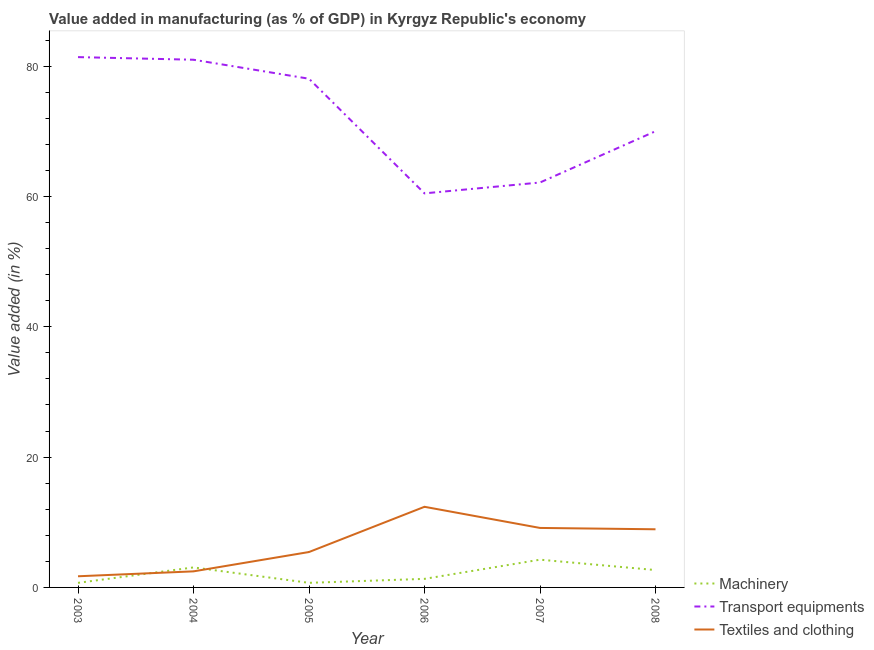How many different coloured lines are there?
Your response must be concise. 3. Is the number of lines equal to the number of legend labels?
Ensure brevity in your answer.  Yes. What is the value added in manufacturing textile and clothing in 2006?
Ensure brevity in your answer.  12.37. Across all years, what is the maximum value added in manufacturing machinery?
Your answer should be compact. 4.26. Across all years, what is the minimum value added in manufacturing transport equipments?
Your answer should be very brief. 60.48. What is the total value added in manufacturing textile and clothing in the graph?
Keep it short and to the point. 40.04. What is the difference between the value added in manufacturing transport equipments in 2007 and that in 2008?
Ensure brevity in your answer.  -7.87. What is the difference between the value added in manufacturing machinery in 2006 and the value added in manufacturing textile and clothing in 2005?
Give a very brief answer. -4.12. What is the average value added in manufacturing textile and clothing per year?
Provide a succinct answer. 6.67. In the year 2007, what is the difference between the value added in manufacturing machinery and value added in manufacturing textile and clothing?
Provide a succinct answer. -4.87. In how many years, is the value added in manufacturing textile and clothing greater than 20 %?
Your response must be concise. 0. What is the ratio of the value added in manufacturing textile and clothing in 2004 to that in 2006?
Ensure brevity in your answer.  0.2. What is the difference between the highest and the second highest value added in manufacturing textile and clothing?
Your answer should be compact. 3.25. What is the difference between the highest and the lowest value added in manufacturing machinery?
Provide a short and direct response. 3.56. Is it the case that in every year, the sum of the value added in manufacturing machinery and value added in manufacturing transport equipments is greater than the value added in manufacturing textile and clothing?
Your answer should be very brief. Yes. How many lines are there?
Your answer should be compact. 3. Does the graph contain grids?
Keep it short and to the point. No. How many legend labels are there?
Your response must be concise. 3. What is the title of the graph?
Your answer should be very brief. Value added in manufacturing (as % of GDP) in Kyrgyz Republic's economy. What is the label or title of the Y-axis?
Ensure brevity in your answer.  Value added (in %). What is the Value added (in %) in Machinery in 2003?
Ensure brevity in your answer.  0.7. What is the Value added (in %) of Transport equipments in 2003?
Provide a short and direct response. 81.39. What is the Value added (in %) of Textiles and clothing in 2003?
Offer a very short reply. 1.71. What is the Value added (in %) in Machinery in 2004?
Provide a short and direct response. 3.07. What is the Value added (in %) in Transport equipments in 2004?
Provide a short and direct response. 80.98. What is the Value added (in %) in Textiles and clothing in 2004?
Your response must be concise. 2.46. What is the Value added (in %) in Machinery in 2005?
Provide a succinct answer. 0.7. What is the Value added (in %) of Transport equipments in 2005?
Your answer should be compact. 78.07. What is the Value added (in %) in Textiles and clothing in 2005?
Give a very brief answer. 5.43. What is the Value added (in %) in Machinery in 2006?
Provide a succinct answer. 1.31. What is the Value added (in %) of Transport equipments in 2006?
Your answer should be compact. 60.48. What is the Value added (in %) of Textiles and clothing in 2006?
Make the answer very short. 12.37. What is the Value added (in %) of Machinery in 2007?
Make the answer very short. 4.26. What is the Value added (in %) of Transport equipments in 2007?
Provide a short and direct response. 62.14. What is the Value added (in %) in Textiles and clothing in 2007?
Offer a terse response. 9.13. What is the Value added (in %) in Machinery in 2008?
Offer a very short reply. 2.67. What is the Value added (in %) of Transport equipments in 2008?
Give a very brief answer. 70.01. What is the Value added (in %) of Textiles and clothing in 2008?
Your answer should be compact. 8.92. Across all years, what is the maximum Value added (in %) in Machinery?
Offer a very short reply. 4.26. Across all years, what is the maximum Value added (in %) in Transport equipments?
Provide a succinct answer. 81.39. Across all years, what is the maximum Value added (in %) of Textiles and clothing?
Your response must be concise. 12.37. Across all years, what is the minimum Value added (in %) in Machinery?
Provide a succinct answer. 0.7. Across all years, what is the minimum Value added (in %) of Transport equipments?
Provide a short and direct response. 60.48. Across all years, what is the minimum Value added (in %) of Textiles and clothing?
Ensure brevity in your answer.  1.71. What is the total Value added (in %) in Machinery in the graph?
Keep it short and to the point. 12.72. What is the total Value added (in %) in Transport equipments in the graph?
Your answer should be very brief. 433.07. What is the total Value added (in %) of Textiles and clothing in the graph?
Your answer should be very brief. 40.04. What is the difference between the Value added (in %) in Machinery in 2003 and that in 2004?
Ensure brevity in your answer.  -2.37. What is the difference between the Value added (in %) in Transport equipments in 2003 and that in 2004?
Give a very brief answer. 0.4. What is the difference between the Value added (in %) of Textiles and clothing in 2003 and that in 2004?
Provide a short and direct response. -0.75. What is the difference between the Value added (in %) in Machinery in 2003 and that in 2005?
Provide a short and direct response. -0. What is the difference between the Value added (in %) of Transport equipments in 2003 and that in 2005?
Give a very brief answer. 3.32. What is the difference between the Value added (in %) of Textiles and clothing in 2003 and that in 2005?
Offer a terse response. -3.72. What is the difference between the Value added (in %) of Machinery in 2003 and that in 2006?
Give a very brief answer. -0.61. What is the difference between the Value added (in %) of Transport equipments in 2003 and that in 2006?
Offer a terse response. 20.91. What is the difference between the Value added (in %) in Textiles and clothing in 2003 and that in 2006?
Keep it short and to the point. -10.66. What is the difference between the Value added (in %) of Machinery in 2003 and that in 2007?
Give a very brief answer. -3.56. What is the difference between the Value added (in %) in Transport equipments in 2003 and that in 2007?
Provide a short and direct response. 19.24. What is the difference between the Value added (in %) of Textiles and clothing in 2003 and that in 2007?
Give a very brief answer. -7.42. What is the difference between the Value added (in %) of Machinery in 2003 and that in 2008?
Your answer should be very brief. -1.96. What is the difference between the Value added (in %) in Transport equipments in 2003 and that in 2008?
Keep it short and to the point. 11.37. What is the difference between the Value added (in %) of Textiles and clothing in 2003 and that in 2008?
Make the answer very short. -7.21. What is the difference between the Value added (in %) of Machinery in 2004 and that in 2005?
Offer a terse response. 2.37. What is the difference between the Value added (in %) of Transport equipments in 2004 and that in 2005?
Offer a terse response. 2.92. What is the difference between the Value added (in %) of Textiles and clothing in 2004 and that in 2005?
Provide a succinct answer. -2.97. What is the difference between the Value added (in %) in Machinery in 2004 and that in 2006?
Your answer should be very brief. 1.76. What is the difference between the Value added (in %) of Transport equipments in 2004 and that in 2006?
Your response must be concise. 20.51. What is the difference between the Value added (in %) in Textiles and clothing in 2004 and that in 2006?
Your response must be concise. -9.91. What is the difference between the Value added (in %) of Machinery in 2004 and that in 2007?
Provide a short and direct response. -1.19. What is the difference between the Value added (in %) in Transport equipments in 2004 and that in 2007?
Offer a terse response. 18.84. What is the difference between the Value added (in %) of Textiles and clothing in 2004 and that in 2007?
Your answer should be compact. -6.66. What is the difference between the Value added (in %) in Machinery in 2004 and that in 2008?
Provide a short and direct response. 0.4. What is the difference between the Value added (in %) of Transport equipments in 2004 and that in 2008?
Give a very brief answer. 10.97. What is the difference between the Value added (in %) in Textiles and clothing in 2004 and that in 2008?
Give a very brief answer. -6.46. What is the difference between the Value added (in %) in Machinery in 2005 and that in 2006?
Your answer should be very brief. -0.61. What is the difference between the Value added (in %) of Transport equipments in 2005 and that in 2006?
Provide a succinct answer. 17.59. What is the difference between the Value added (in %) of Textiles and clothing in 2005 and that in 2006?
Your answer should be compact. -6.94. What is the difference between the Value added (in %) of Machinery in 2005 and that in 2007?
Your answer should be compact. -3.55. What is the difference between the Value added (in %) of Transport equipments in 2005 and that in 2007?
Give a very brief answer. 15.93. What is the difference between the Value added (in %) of Textiles and clothing in 2005 and that in 2007?
Make the answer very short. -3.7. What is the difference between the Value added (in %) in Machinery in 2005 and that in 2008?
Provide a succinct answer. -1.96. What is the difference between the Value added (in %) of Transport equipments in 2005 and that in 2008?
Your answer should be very brief. 8.06. What is the difference between the Value added (in %) of Textiles and clothing in 2005 and that in 2008?
Keep it short and to the point. -3.49. What is the difference between the Value added (in %) of Machinery in 2006 and that in 2007?
Offer a terse response. -2.94. What is the difference between the Value added (in %) of Transport equipments in 2006 and that in 2007?
Give a very brief answer. -1.67. What is the difference between the Value added (in %) of Textiles and clothing in 2006 and that in 2007?
Ensure brevity in your answer.  3.25. What is the difference between the Value added (in %) of Machinery in 2006 and that in 2008?
Offer a very short reply. -1.35. What is the difference between the Value added (in %) of Transport equipments in 2006 and that in 2008?
Your answer should be very brief. -9.54. What is the difference between the Value added (in %) in Textiles and clothing in 2006 and that in 2008?
Your answer should be very brief. 3.45. What is the difference between the Value added (in %) in Machinery in 2007 and that in 2008?
Provide a short and direct response. 1.59. What is the difference between the Value added (in %) in Transport equipments in 2007 and that in 2008?
Your answer should be compact. -7.87. What is the difference between the Value added (in %) of Textiles and clothing in 2007 and that in 2008?
Your answer should be very brief. 0.21. What is the difference between the Value added (in %) of Machinery in 2003 and the Value added (in %) of Transport equipments in 2004?
Provide a short and direct response. -80.28. What is the difference between the Value added (in %) in Machinery in 2003 and the Value added (in %) in Textiles and clothing in 2004?
Make the answer very short. -1.76. What is the difference between the Value added (in %) of Transport equipments in 2003 and the Value added (in %) of Textiles and clothing in 2004?
Make the answer very short. 78.92. What is the difference between the Value added (in %) of Machinery in 2003 and the Value added (in %) of Transport equipments in 2005?
Make the answer very short. -77.37. What is the difference between the Value added (in %) in Machinery in 2003 and the Value added (in %) in Textiles and clothing in 2005?
Your answer should be very brief. -4.73. What is the difference between the Value added (in %) of Transport equipments in 2003 and the Value added (in %) of Textiles and clothing in 2005?
Your answer should be compact. 75.95. What is the difference between the Value added (in %) of Machinery in 2003 and the Value added (in %) of Transport equipments in 2006?
Offer a terse response. -59.77. What is the difference between the Value added (in %) of Machinery in 2003 and the Value added (in %) of Textiles and clothing in 2006?
Your answer should be compact. -11.67. What is the difference between the Value added (in %) in Transport equipments in 2003 and the Value added (in %) in Textiles and clothing in 2006?
Provide a succinct answer. 69.01. What is the difference between the Value added (in %) of Machinery in 2003 and the Value added (in %) of Transport equipments in 2007?
Provide a short and direct response. -61.44. What is the difference between the Value added (in %) of Machinery in 2003 and the Value added (in %) of Textiles and clothing in 2007?
Your answer should be very brief. -8.43. What is the difference between the Value added (in %) of Transport equipments in 2003 and the Value added (in %) of Textiles and clothing in 2007?
Provide a succinct answer. 72.26. What is the difference between the Value added (in %) of Machinery in 2003 and the Value added (in %) of Transport equipments in 2008?
Your answer should be compact. -69.31. What is the difference between the Value added (in %) of Machinery in 2003 and the Value added (in %) of Textiles and clothing in 2008?
Your answer should be compact. -8.22. What is the difference between the Value added (in %) of Transport equipments in 2003 and the Value added (in %) of Textiles and clothing in 2008?
Offer a terse response. 72.46. What is the difference between the Value added (in %) in Machinery in 2004 and the Value added (in %) in Transport equipments in 2005?
Your answer should be very brief. -75. What is the difference between the Value added (in %) in Machinery in 2004 and the Value added (in %) in Textiles and clothing in 2005?
Your answer should be compact. -2.36. What is the difference between the Value added (in %) in Transport equipments in 2004 and the Value added (in %) in Textiles and clothing in 2005?
Provide a succinct answer. 75.55. What is the difference between the Value added (in %) in Machinery in 2004 and the Value added (in %) in Transport equipments in 2006?
Provide a short and direct response. -57.41. What is the difference between the Value added (in %) of Machinery in 2004 and the Value added (in %) of Textiles and clothing in 2006?
Give a very brief answer. -9.3. What is the difference between the Value added (in %) in Transport equipments in 2004 and the Value added (in %) in Textiles and clothing in 2006?
Your answer should be compact. 68.61. What is the difference between the Value added (in %) in Machinery in 2004 and the Value added (in %) in Transport equipments in 2007?
Offer a terse response. -59.07. What is the difference between the Value added (in %) of Machinery in 2004 and the Value added (in %) of Textiles and clothing in 2007?
Keep it short and to the point. -6.06. What is the difference between the Value added (in %) in Transport equipments in 2004 and the Value added (in %) in Textiles and clothing in 2007?
Offer a terse response. 71.85. What is the difference between the Value added (in %) in Machinery in 2004 and the Value added (in %) in Transport equipments in 2008?
Provide a short and direct response. -66.94. What is the difference between the Value added (in %) in Machinery in 2004 and the Value added (in %) in Textiles and clothing in 2008?
Your answer should be compact. -5.85. What is the difference between the Value added (in %) in Transport equipments in 2004 and the Value added (in %) in Textiles and clothing in 2008?
Keep it short and to the point. 72.06. What is the difference between the Value added (in %) of Machinery in 2005 and the Value added (in %) of Transport equipments in 2006?
Offer a terse response. -59.77. What is the difference between the Value added (in %) in Machinery in 2005 and the Value added (in %) in Textiles and clothing in 2006?
Ensure brevity in your answer.  -11.67. What is the difference between the Value added (in %) of Transport equipments in 2005 and the Value added (in %) of Textiles and clothing in 2006?
Provide a succinct answer. 65.69. What is the difference between the Value added (in %) of Machinery in 2005 and the Value added (in %) of Transport equipments in 2007?
Ensure brevity in your answer.  -61.44. What is the difference between the Value added (in %) of Machinery in 2005 and the Value added (in %) of Textiles and clothing in 2007?
Make the answer very short. -8.43. What is the difference between the Value added (in %) of Transport equipments in 2005 and the Value added (in %) of Textiles and clothing in 2007?
Give a very brief answer. 68.94. What is the difference between the Value added (in %) of Machinery in 2005 and the Value added (in %) of Transport equipments in 2008?
Give a very brief answer. -69.31. What is the difference between the Value added (in %) in Machinery in 2005 and the Value added (in %) in Textiles and clothing in 2008?
Offer a terse response. -8.22. What is the difference between the Value added (in %) in Transport equipments in 2005 and the Value added (in %) in Textiles and clothing in 2008?
Keep it short and to the point. 69.15. What is the difference between the Value added (in %) in Machinery in 2006 and the Value added (in %) in Transport equipments in 2007?
Keep it short and to the point. -60.83. What is the difference between the Value added (in %) of Machinery in 2006 and the Value added (in %) of Textiles and clothing in 2007?
Give a very brief answer. -7.82. What is the difference between the Value added (in %) of Transport equipments in 2006 and the Value added (in %) of Textiles and clothing in 2007?
Offer a terse response. 51.35. What is the difference between the Value added (in %) of Machinery in 2006 and the Value added (in %) of Transport equipments in 2008?
Provide a short and direct response. -68.7. What is the difference between the Value added (in %) in Machinery in 2006 and the Value added (in %) in Textiles and clothing in 2008?
Provide a short and direct response. -7.61. What is the difference between the Value added (in %) in Transport equipments in 2006 and the Value added (in %) in Textiles and clothing in 2008?
Ensure brevity in your answer.  51.55. What is the difference between the Value added (in %) in Machinery in 2007 and the Value added (in %) in Transport equipments in 2008?
Make the answer very short. -65.75. What is the difference between the Value added (in %) of Machinery in 2007 and the Value added (in %) of Textiles and clothing in 2008?
Ensure brevity in your answer.  -4.67. What is the difference between the Value added (in %) in Transport equipments in 2007 and the Value added (in %) in Textiles and clothing in 2008?
Make the answer very short. 53.22. What is the average Value added (in %) of Machinery per year?
Your answer should be very brief. 2.12. What is the average Value added (in %) in Transport equipments per year?
Offer a terse response. 72.18. What is the average Value added (in %) of Textiles and clothing per year?
Your answer should be very brief. 6.67. In the year 2003, what is the difference between the Value added (in %) in Machinery and Value added (in %) in Transport equipments?
Offer a very short reply. -80.68. In the year 2003, what is the difference between the Value added (in %) in Machinery and Value added (in %) in Textiles and clothing?
Make the answer very short. -1.01. In the year 2003, what is the difference between the Value added (in %) of Transport equipments and Value added (in %) of Textiles and clothing?
Provide a short and direct response. 79.67. In the year 2004, what is the difference between the Value added (in %) of Machinery and Value added (in %) of Transport equipments?
Keep it short and to the point. -77.91. In the year 2004, what is the difference between the Value added (in %) in Machinery and Value added (in %) in Textiles and clothing?
Keep it short and to the point. 0.61. In the year 2004, what is the difference between the Value added (in %) of Transport equipments and Value added (in %) of Textiles and clothing?
Make the answer very short. 78.52. In the year 2005, what is the difference between the Value added (in %) of Machinery and Value added (in %) of Transport equipments?
Your answer should be very brief. -77.36. In the year 2005, what is the difference between the Value added (in %) of Machinery and Value added (in %) of Textiles and clothing?
Your response must be concise. -4.73. In the year 2005, what is the difference between the Value added (in %) of Transport equipments and Value added (in %) of Textiles and clothing?
Offer a very short reply. 72.64. In the year 2006, what is the difference between the Value added (in %) in Machinery and Value added (in %) in Transport equipments?
Provide a short and direct response. -59.16. In the year 2006, what is the difference between the Value added (in %) of Machinery and Value added (in %) of Textiles and clothing?
Provide a succinct answer. -11.06. In the year 2006, what is the difference between the Value added (in %) of Transport equipments and Value added (in %) of Textiles and clothing?
Provide a short and direct response. 48.1. In the year 2007, what is the difference between the Value added (in %) of Machinery and Value added (in %) of Transport equipments?
Offer a terse response. -57.88. In the year 2007, what is the difference between the Value added (in %) of Machinery and Value added (in %) of Textiles and clothing?
Your answer should be very brief. -4.87. In the year 2007, what is the difference between the Value added (in %) in Transport equipments and Value added (in %) in Textiles and clothing?
Give a very brief answer. 53.01. In the year 2008, what is the difference between the Value added (in %) of Machinery and Value added (in %) of Transport equipments?
Provide a succinct answer. -67.34. In the year 2008, what is the difference between the Value added (in %) in Machinery and Value added (in %) in Textiles and clothing?
Your answer should be very brief. -6.26. In the year 2008, what is the difference between the Value added (in %) of Transport equipments and Value added (in %) of Textiles and clothing?
Your answer should be very brief. 61.09. What is the ratio of the Value added (in %) of Machinery in 2003 to that in 2004?
Provide a succinct answer. 0.23. What is the ratio of the Value added (in %) of Textiles and clothing in 2003 to that in 2004?
Keep it short and to the point. 0.69. What is the ratio of the Value added (in %) of Transport equipments in 2003 to that in 2005?
Keep it short and to the point. 1.04. What is the ratio of the Value added (in %) in Textiles and clothing in 2003 to that in 2005?
Your response must be concise. 0.32. What is the ratio of the Value added (in %) of Machinery in 2003 to that in 2006?
Offer a very short reply. 0.53. What is the ratio of the Value added (in %) in Transport equipments in 2003 to that in 2006?
Offer a very short reply. 1.35. What is the ratio of the Value added (in %) in Textiles and clothing in 2003 to that in 2006?
Your answer should be compact. 0.14. What is the ratio of the Value added (in %) in Machinery in 2003 to that in 2007?
Your response must be concise. 0.17. What is the ratio of the Value added (in %) of Transport equipments in 2003 to that in 2007?
Ensure brevity in your answer.  1.31. What is the ratio of the Value added (in %) of Textiles and clothing in 2003 to that in 2007?
Ensure brevity in your answer.  0.19. What is the ratio of the Value added (in %) in Machinery in 2003 to that in 2008?
Ensure brevity in your answer.  0.26. What is the ratio of the Value added (in %) of Transport equipments in 2003 to that in 2008?
Offer a very short reply. 1.16. What is the ratio of the Value added (in %) of Textiles and clothing in 2003 to that in 2008?
Provide a short and direct response. 0.19. What is the ratio of the Value added (in %) in Machinery in 2004 to that in 2005?
Provide a short and direct response. 4.36. What is the ratio of the Value added (in %) of Transport equipments in 2004 to that in 2005?
Your answer should be compact. 1.04. What is the ratio of the Value added (in %) of Textiles and clothing in 2004 to that in 2005?
Provide a short and direct response. 0.45. What is the ratio of the Value added (in %) of Machinery in 2004 to that in 2006?
Offer a terse response. 2.34. What is the ratio of the Value added (in %) in Transport equipments in 2004 to that in 2006?
Offer a very short reply. 1.34. What is the ratio of the Value added (in %) of Textiles and clothing in 2004 to that in 2006?
Your response must be concise. 0.2. What is the ratio of the Value added (in %) of Machinery in 2004 to that in 2007?
Ensure brevity in your answer.  0.72. What is the ratio of the Value added (in %) of Transport equipments in 2004 to that in 2007?
Offer a very short reply. 1.3. What is the ratio of the Value added (in %) in Textiles and clothing in 2004 to that in 2007?
Your response must be concise. 0.27. What is the ratio of the Value added (in %) of Machinery in 2004 to that in 2008?
Your response must be concise. 1.15. What is the ratio of the Value added (in %) in Transport equipments in 2004 to that in 2008?
Keep it short and to the point. 1.16. What is the ratio of the Value added (in %) of Textiles and clothing in 2004 to that in 2008?
Offer a very short reply. 0.28. What is the ratio of the Value added (in %) in Machinery in 2005 to that in 2006?
Keep it short and to the point. 0.54. What is the ratio of the Value added (in %) in Transport equipments in 2005 to that in 2006?
Ensure brevity in your answer.  1.29. What is the ratio of the Value added (in %) in Textiles and clothing in 2005 to that in 2006?
Give a very brief answer. 0.44. What is the ratio of the Value added (in %) of Machinery in 2005 to that in 2007?
Ensure brevity in your answer.  0.17. What is the ratio of the Value added (in %) of Transport equipments in 2005 to that in 2007?
Offer a terse response. 1.26. What is the ratio of the Value added (in %) of Textiles and clothing in 2005 to that in 2007?
Make the answer very short. 0.6. What is the ratio of the Value added (in %) in Machinery in 2005 to that in 2008?
Provide a succinct answer. 0.26. What is the ratio of the Value added (in %) in Transport equipments in 2005 to that in 2008?
Provide a short and direct response. 1.12. What is the ratio of the Value added (in %) in Textiles and clothing in 2005 to that in 2008?
Provide a succinct answer. 0.61. What is the ratio of the Value added (in %) in Machinery in 2006 to that in 2007?
Make the answer very short. 0.31. What is the ratio of the Value added (in %) of Transport equipments in 2006 to that in 2007?
Your response must be concise. 0.97. What is the ratio of the Value added (in %) of Textiles and clothing in 2006 to that in 2007?
Provide a succinct answer. 1.36. What is the ratio of the Value added (in %) of Machinery in 2006 to that in 2008?
Your response must be concise. 0.49. What is the ratio of the Value added (in %) in Transport equipments in 2006 to that in 2008?
Your answer should be very brief. 0.86. What is the ratio of the Value added (in %) in Textiles and clothing in 2006 to that in 2008?
Ensure brevity in your answer.  1.39. What is the ratio of the Value added (in %) of Machinery in 2007 to that in 2008?
Your answer should be very brief. 1.6. What is the ratio of the Value added (in %) in Transport equipments in 2007 to that in 2008?
Provide a short and direct response. 0.89. What is the ratio of the Value added (in %) in Textiles and clothing in 2007 to that in 2008?
Ensure brevity in your answer.  1.02. What is the difference between the highest and the second highest Value added (in %) of Machinery?
Provide a succinct answer. 1.19. What is the difference between the highest and the second highest Value added (in %) of Transport equipments?
Offer a terse response. 0.4. What is the difference between the highest and the second highest Value added (in %) in Textiles and clothing?
Offer a very short reply. 3.25. What is the difference between the highest and the lowest Value added (in %) of Machinery?
Provide a short and direct response. 3.56. What is the difference between the highest and the lowest Value added (in %) in Transport equipments?
Provide a short and direct response. 20.91. What is the difference between the highest and the lowest Value added (in %) in Textiles and clothing?
Offer a terse response. 10.66. 